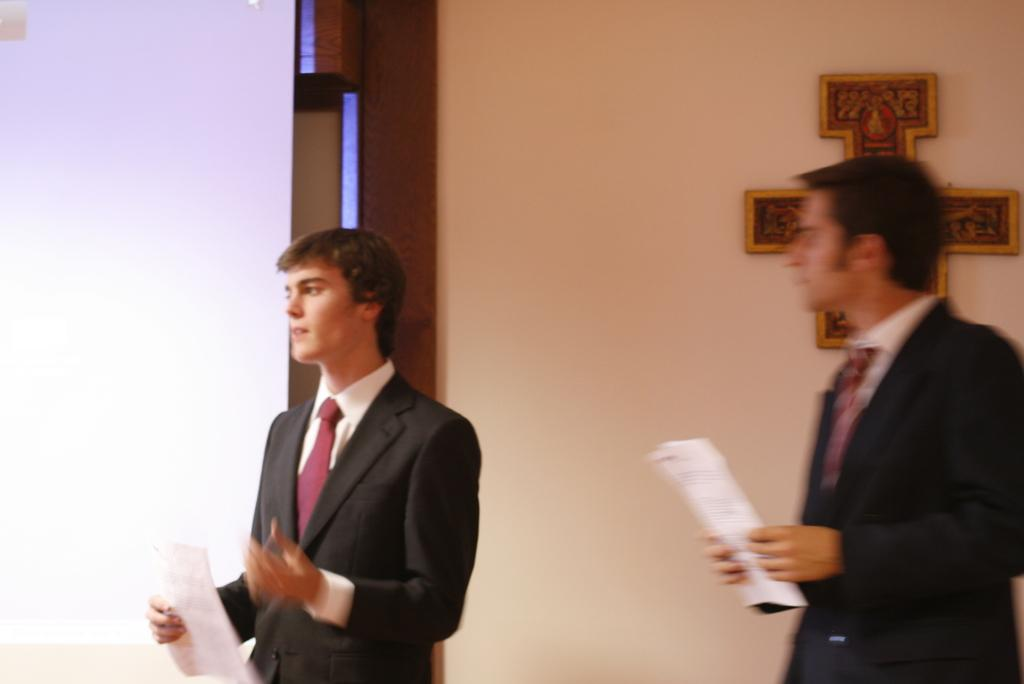How many people are in the image? There are two persons in the image. What are the persons doing in the image? The persons are standing and holding papers in their hands. What can be seen in the background of the image? There is a wall in the background of the image. What is the price of the ice in the image? There is no ice or price present in the image. What type of wrench is being used by the persons in the image? There is no wrench visible in the image. 